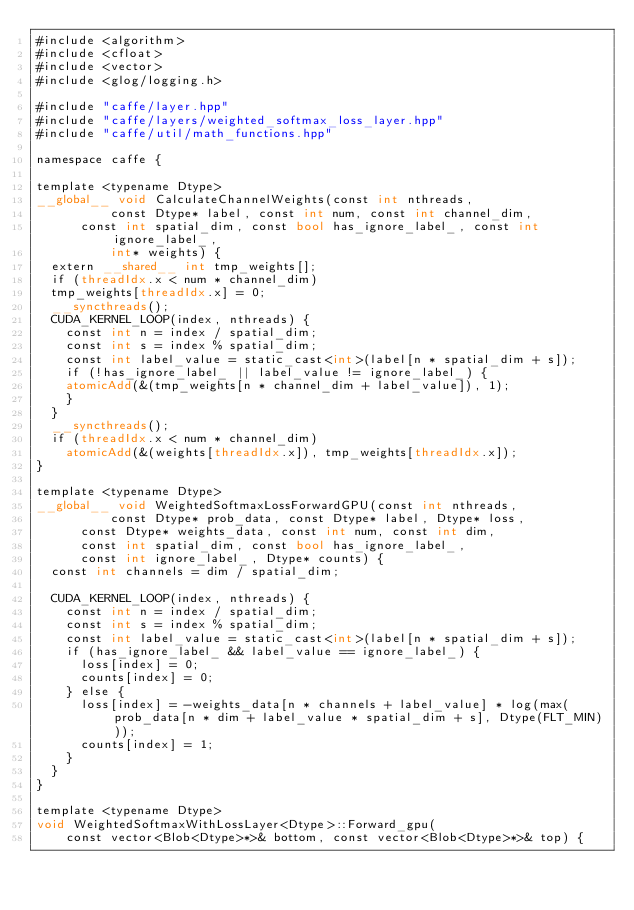Convert code to text. <code><loc_0><loc_0><loc_500><loc_500><_Cuda_>#include <algorithm>
#include <cfloat>
#include <vector>
#include <glog/logging.h>

#include "caffe/layer.hpp"
#include "caffe/layers/weighted_softmax_loss_layer.hpp"
#include "caffe/util/math_functions.hpp"

namespace caffe {  

template <typename Dtype>
__global__ void CalculateChannelWeights(const int nthreads,
          const Dtype* label, const int num, const int channel_dim, 
		  const int spatial_dim, const bool has_ignore_label_, const int ignore_label_,
          int* weights) {
  extern __shared__ int tmp_weights[];
  if (threadIdx.x < num * channel_dim)
	tmp_weights[threadIdx.x] = 0;
  __syncthreads();
  CUDA_KERNEL_LOOP(index, nthreads) {
    const int n = index / spatial_dim;
    const int s = index % spatial_dim;
    const int label_value = static_cast<int>(label[n * spatial_dim + s]);
    if (!has_ignore_label_ || label_value != ignore_label_) {
	  atomicAdd(&(tmp_weights[n * channel_dim + label_value]), 1);
    }
  }
  __syncthreads();
  if (threadIdx.x < num * channel_dim)
    atomicAdd(&(weights[threadIdx.x]), tmp_weights[threadIdx.x]);
}

template <typename Dtype>
__global__ void WeightedSoftmaxLossForwardGPU(const int nthreads,
          const Dtype* prob_data, const Dtype* label, Dtype* loss,
		  const Dtype* weights_data, const int num, const int dim, 
		  const int spatial_dim, const bool has_ignore_label_, 
		  const int ignore_label_, Dtype* counts) {
  const int channels = dim / spatial_dim;

  CUDA_KERNEL_LOOP(index, nthreads) {
    const int n = index / spatial_dim;
    const int s = index % spatial_dim;
    const int label_value = static_cast<int>(label[n * spatial_dim + s]);
    if (has_ignore_label_ && label_value == ignore_label_) {
      loss[index] = 0;
      counts[index] = 0;
    } else {
      loss[index] = -weights_data[n * channels + label_value] * log(max(prob_data[n * dim + label_value * spatial_dim + s], Dtype(FLT_MIN)));
      counts[index] = 1;
    }
  }
}

template <typename Dtype>
void WeightedSoftmaxWithLossLayer<Dtype>::Forward_gpu(
    const vector<Blob<Dtype>*>& bottom, const vector<Blob<Dtype>*>& top) {</code> 